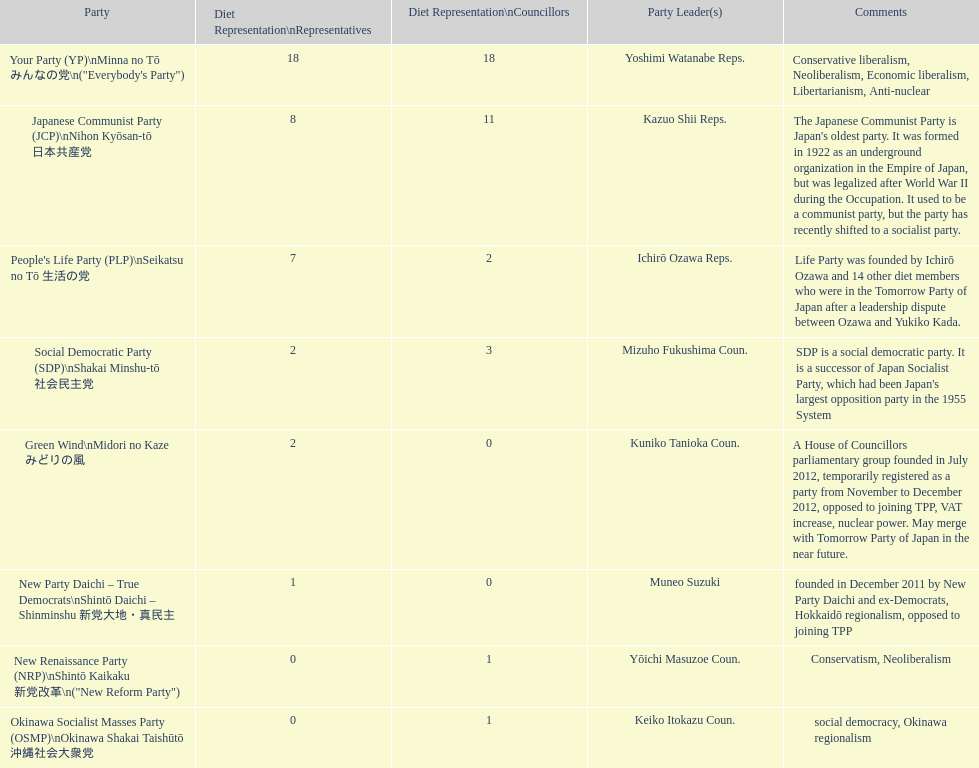How many members of the green wind party serve as representatives? 2. 